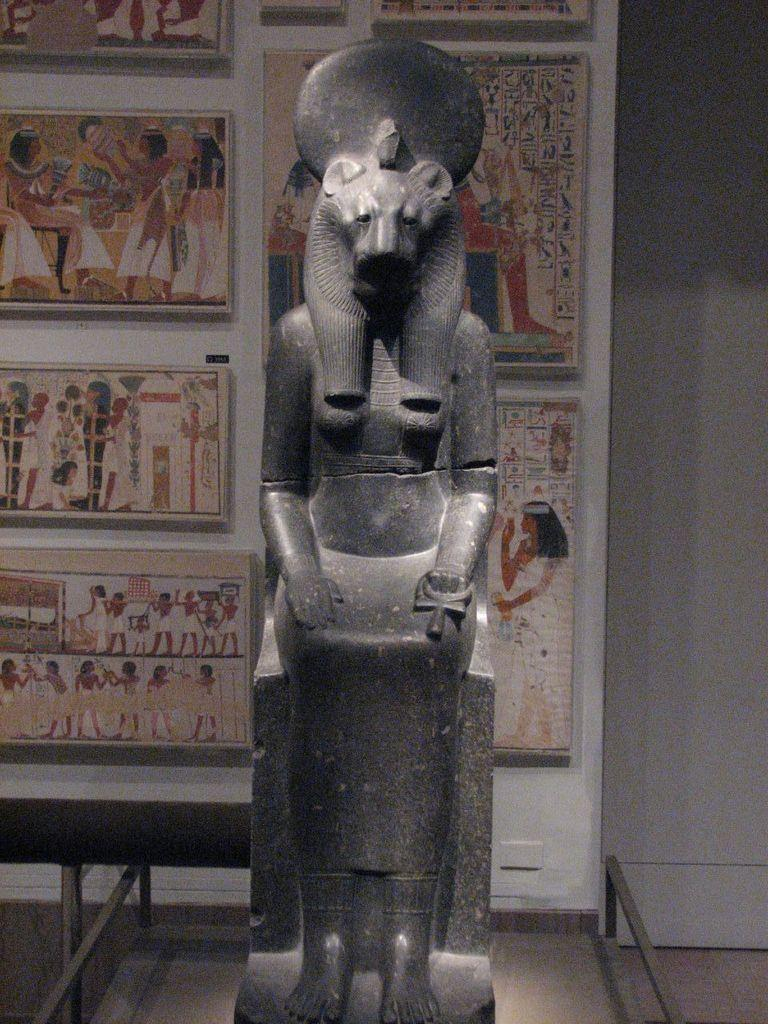What is the main subject of the image? There is a statue in the image. Can you describe the statue's appearance? The statue is black in color. What can be seen in the background of the image? There are photo frames attached to the wall in the background of the image. Where is the bed located in the image? There is no bed present in the image; it only features a statue and photo frames on the wall. Can you tell me how many birds are perched on the statue in the image? There are no birds present in the image; it only features a black statue and photo frames on the wall. 